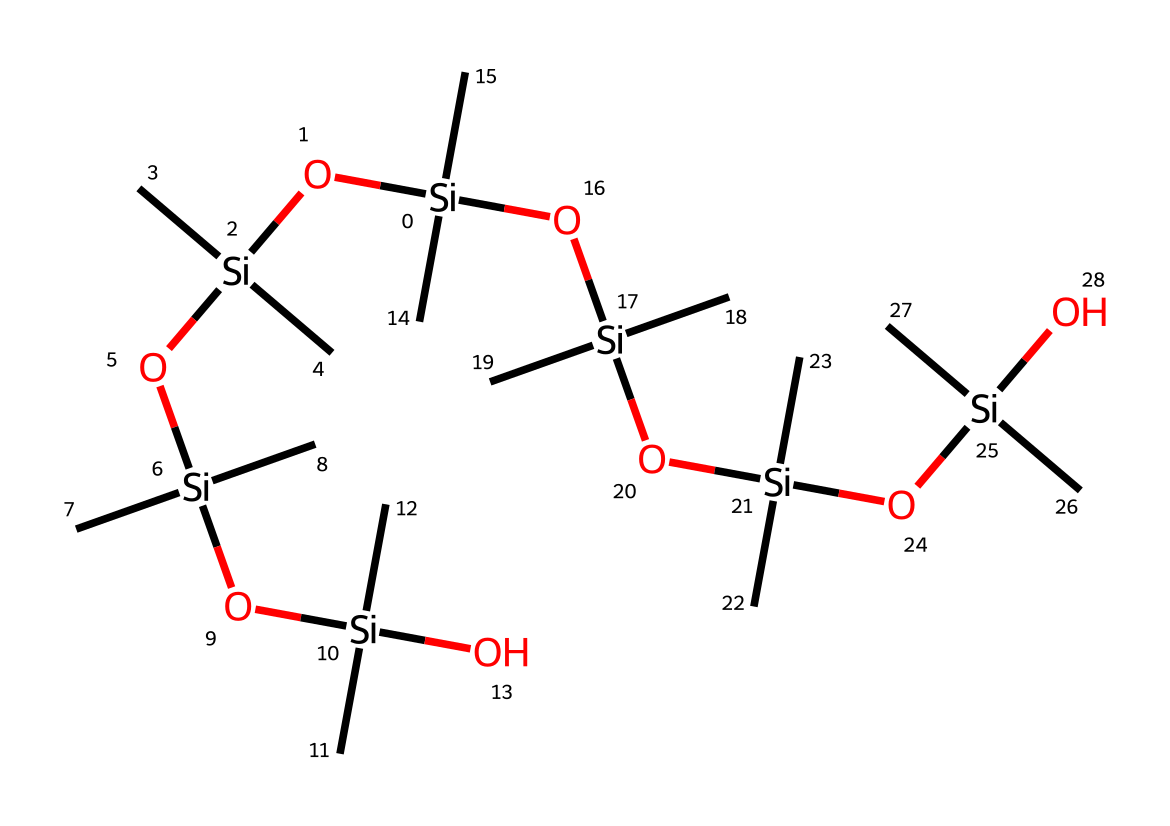what is the central atom in this chemical structure? The SMILES notation shows silicon atoms that are central to the structure. The presence of multiple silicon atoms connected to oxygen tells us that silicon is the primary element around which the structure is built.
Answer: silicon how many oxygen atoms are present in this chemical? By analyzing the SMILES representation, there are six instances of 'O', indicating six oxygen atoms connected to various silicon atoms.
Answer: six what type of bonding is primarily present in this compound? In the chemical structure, silicon atoms are primarily bonded to oxygen atoms through covalent bonds, which is a common feature of organosilicon compounds.
Answer: covalent how many carbon groups are attached to the silicon atoms? Each silicon atom in the representation is connected to two carbon groups, and since there are five silicon atoms listed, that results in a total of ten carbon groups.
Answer: ten what functional groups are indicated in this chemical structure? The structure has hydroxyl (–OH) groups indicated by the presence of oxygen bonded to silicon, demonstrating that this is a silanol or silicone-related compound.
Answer: hydroxyl groups what is the significance of the repeated silicon-oxygen units? The repeating silicon-oxygen units imply a polymeric structure, which is characteristic of silicone materials, providing flexibility and durability for sealing applications.
Answer: polymeric structure 